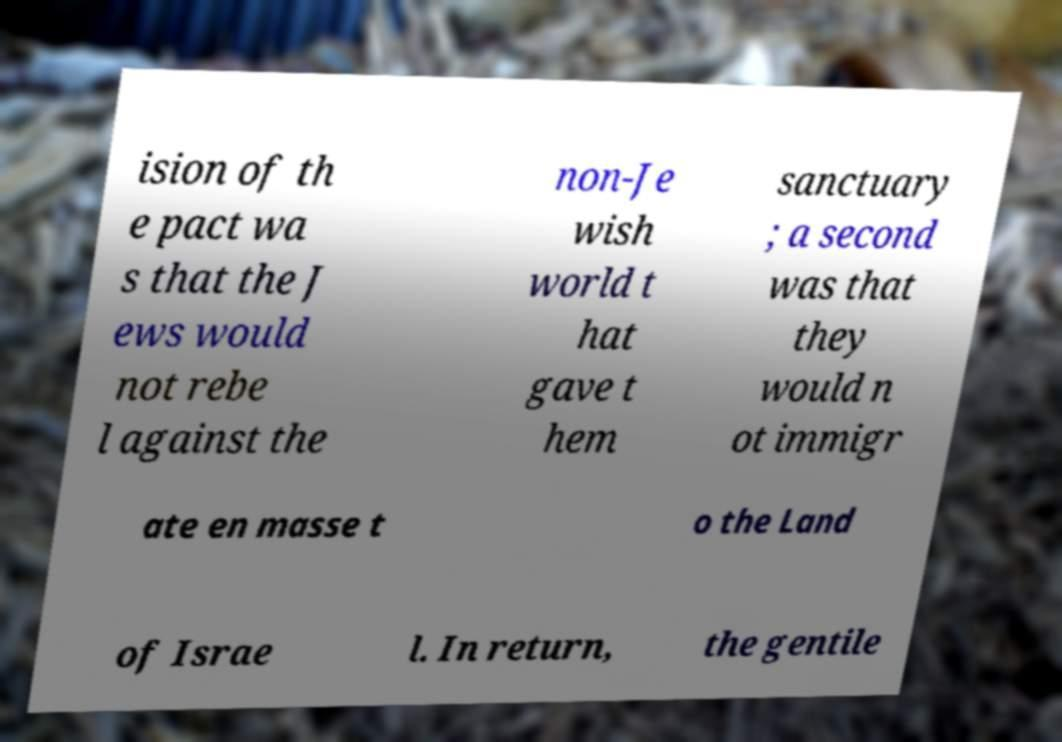There's text embedded in this image that I need extracted. Can you transcribe it verbatim? ision of th e pact wa s that the J ews would not rebe l against the non-Je wish world t hat gave t hem sanctuary ; a second was that they would n ot immigr ate en masse t o the Land of Israe l. In return, the gentile 